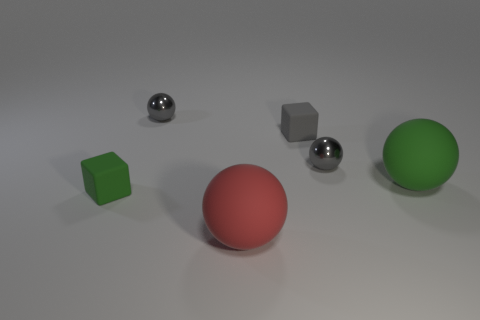Do the small rubber block in front of the big green sphere and the large sphere right of the red sphere have the same color?
Ensure brevity in your answer.  Yes. There is a matte sphere that is behind the rubber ball that is on the left side of the tiny rubber block on the right side of the large red object; what size is it?
Offer a terse response. Large. There is a green rubber thing that is the same shape as the small gray matte thing; what size is it?
Keep it short and to the point. Small. What number of big objects are either cubes or metallic spheres?
Ensure brevity in your answer.  0. Are the green cube that is behind the red rubber thing and the large sphere that is behind the red matte ball made of the same material?
Keep it short and to the point. Yes. There is a tiny gray thing to the left of the small gray rubber block; what is its material?
Give a very brief answer. Metal. What number of metallic things are either small green things or tiny gray cubes?
Offer a terse response. 0. There is a tiny sphere to the right of the gray object that is behind the tiny gray block; what color is it?
Your response must be concise. Gray. Are the small gray block and the gray ball right of the red rubber sphere made of the same material?
Provide a short and direct response. No. There is a tiny thing that is behind the small rubber block to the right of the gray object that is behind the tiny gray cube; what is its color?
Your answer should be very brief. Gray. 